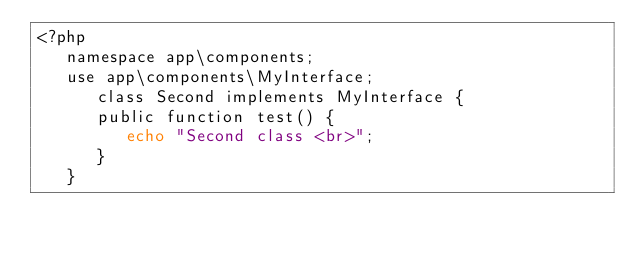Convert code to text. <code><loc_0><loc_0><loc_500><loc_500><_PHP_><?php
   namespace app\components;
   use app\components\MyInterface;
      class Second implements MyInterface {
      public function test() {
         echo "Second class <br>";
      }
   }</code> 